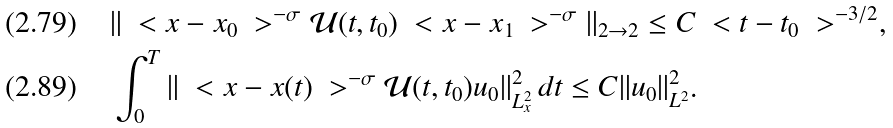Convert formula to latex. <formula><loc_0><loc_0><loc_500><loc_500>& \| \ < x - x _ { 0 } \ > ^ { - \sigma } \mathcal { U } ( t , t _ { 0 } ) \ < x - x _ { 1 } \ > ^ { - \sigma } \| _ { 2 \to 2 } \leq C \ < t - t _ { 0 } \ > ^ { - 3 / 2 } , \\ & \int _ { 0 } ^ { T } \| \ < x - x ( t ) \ > ^ { - \sigma } \mathcal { U } ( t , t _ { 0 } ) u _ { 0 } \| _ { L ^ { 2 } _ { x } } ^ { 2 } \, d t \leq C \| u _ { 0 } \| _ { L ^ { 2 } } ^ { 2 } .</formula> 